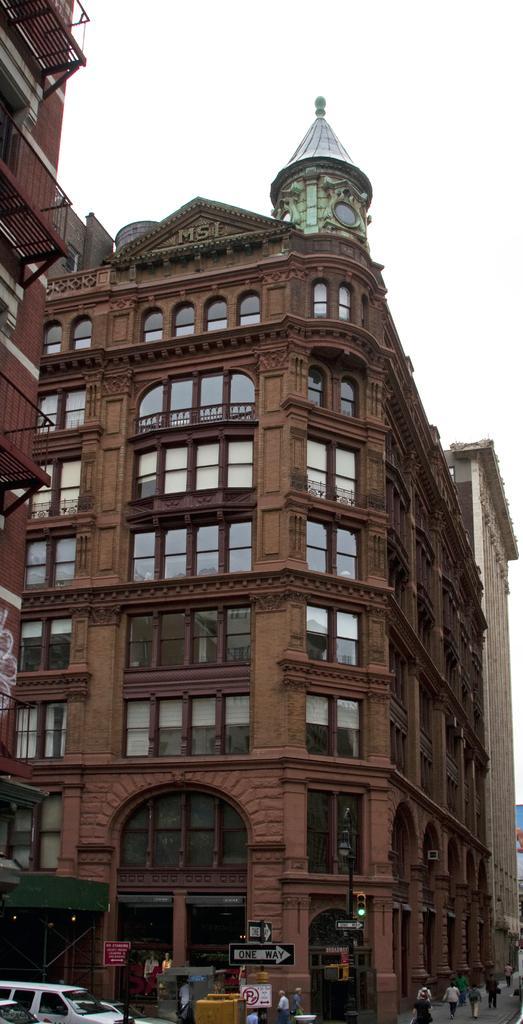Please provide a concise description of this image. In this image we can see the buildings, there are vehicles, people, boards with the text and some other objects on the ground, in the background, we can see the sky. 